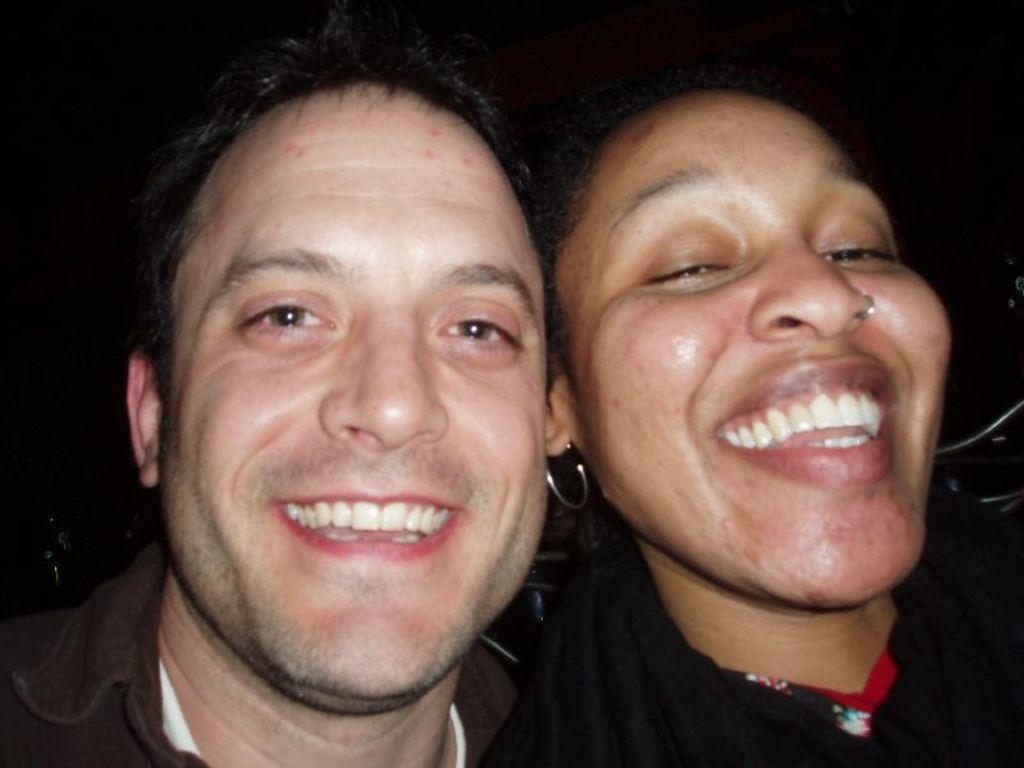Could you give a brief overview of what you see in this image? In this picture we can see two people smiling and in the background we can see some objects and it is dark. 